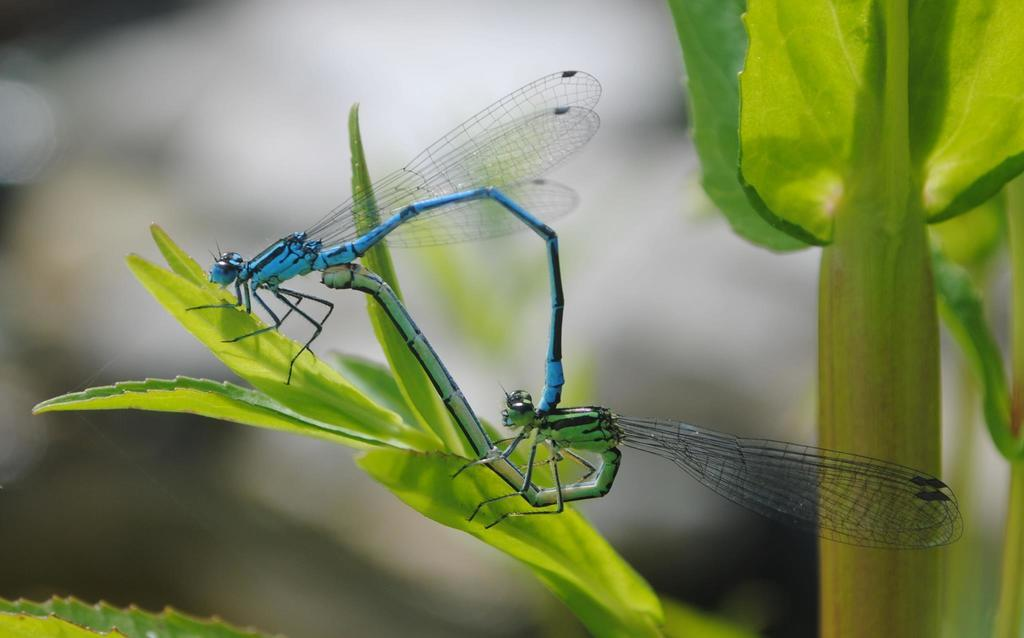What insects can be seen in the image? There are damselflies on the leaves of a plant in the image. Can you describe the background of the image? The background of the image is blurred. What type of rabbit can be seen playing with the damselflies in the image? There is no rabbit present in the image, and the damselflies are not engaged in any playful activities. 